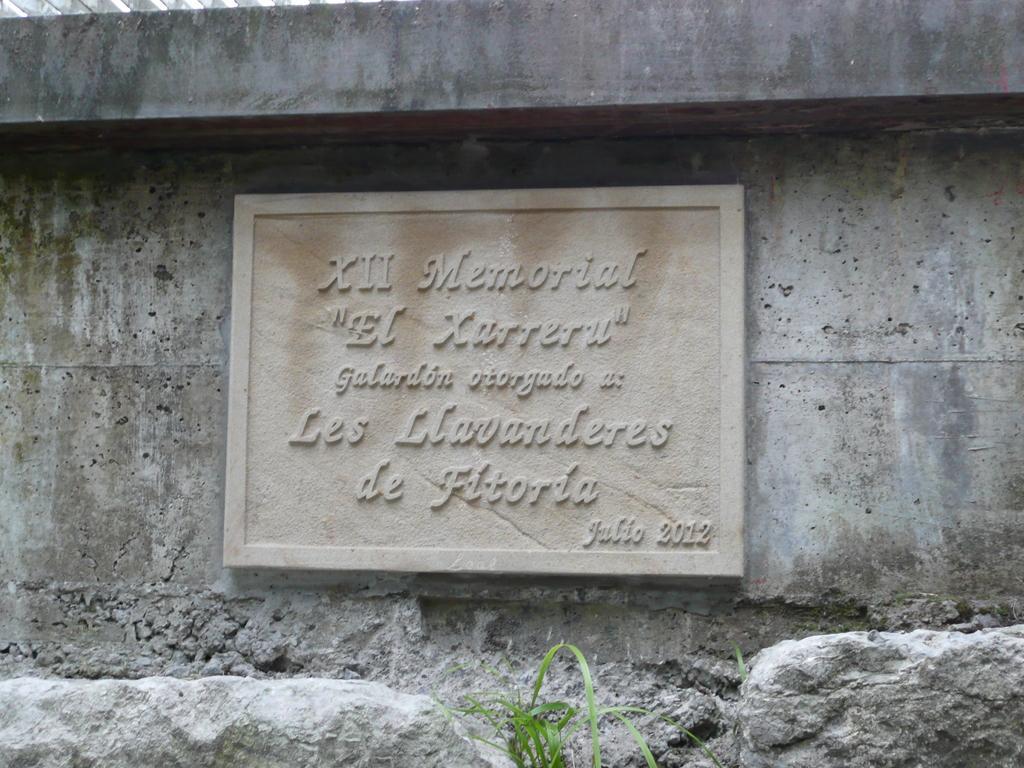Please provide a concise description of this image. In this image we can see one concrete board with text attached to the wall, two rocks near the wall, some grass near the rock and one object on the top left side of the image. 